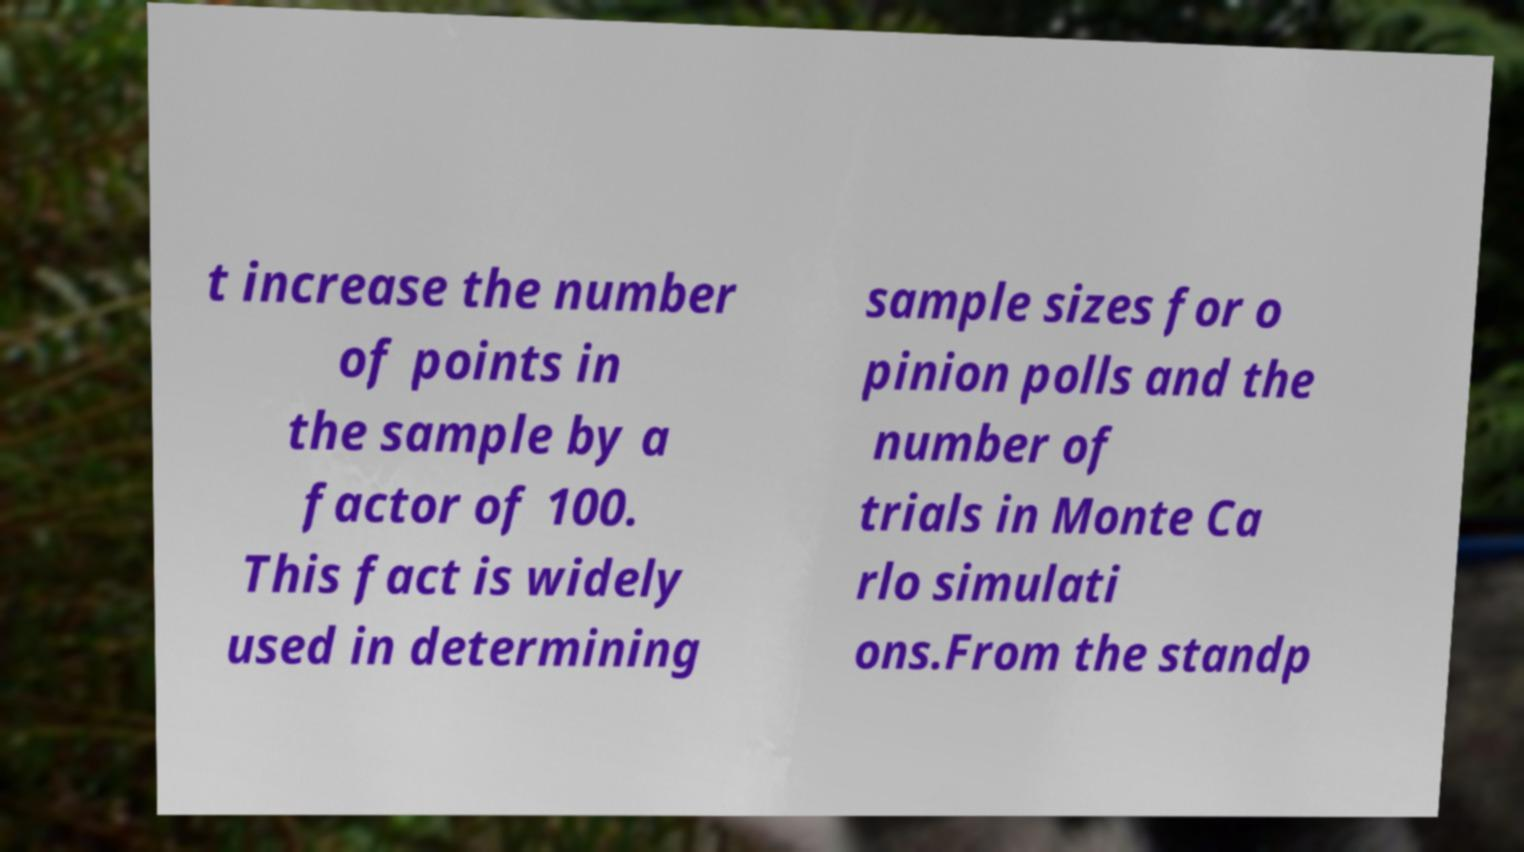Please read and relay the text visible in this image. What does it say? t increase the number of points in the sample by a factor of 100. This fact is widely used in determining sample sizes for o pinion polls and the number of trials in Monte Ca rlo simulati ons.From the standp 